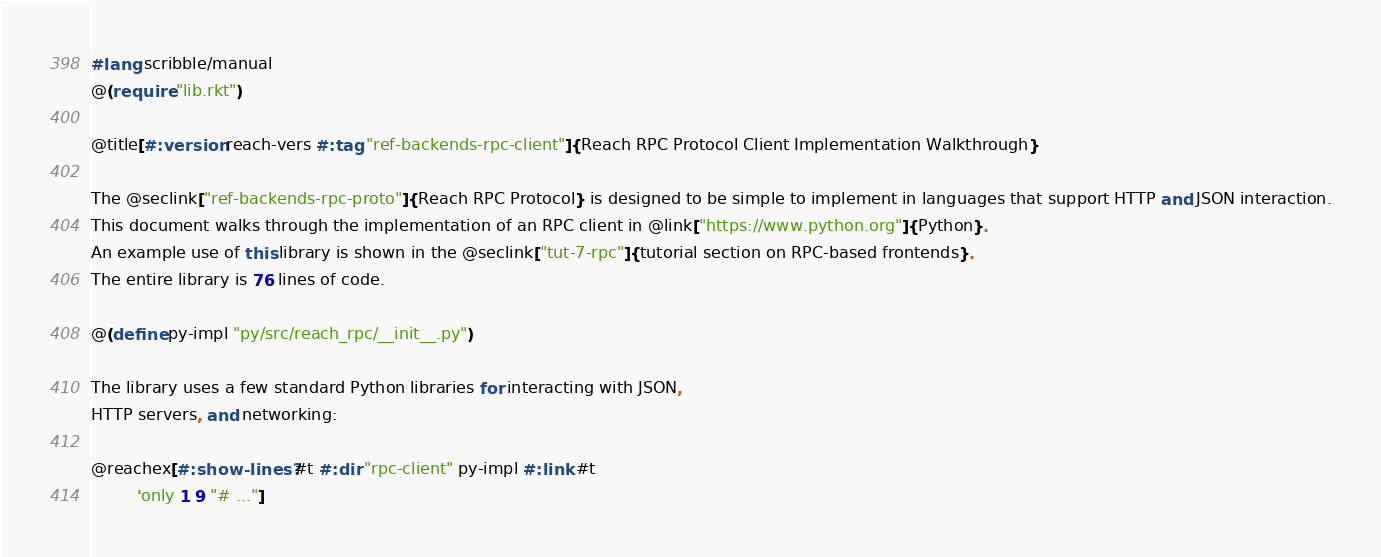<code> <loc_0><loc_0><loc_500><loc_500><_Racket_>#lang scribble/manual
@(require "lib.rkt")

@title[#:version reach-vers #:tag "ref-backends-rpc-client"]{Reach RPC Protocol Client Implementation Walkthrough}

The @seclink["ref-backends-rpc-proto"]{Reach RPC Protocol} is designed to be simple to implement in languages that support HTTP and JSON interaction.
This document walks through the implementation of an RPC client in @link["https://www.python.org"]{Python}.
An example use of this library is shown in the @seclink["tut-7-rpc"]{tutorial section on RPC-based frontends}.
The entire library is 76 lines of code.

@(define py-impl "py/src/reach_rpc/__init__.py")

The library uses a few standard Python libraries for interacting with JSON,
HTTP servers, and networking:

@reachex[#:show-lines? #t #:dir "rpc-client" py-impl #:link #t
         'only 1 9 "# ..."]
</code> 